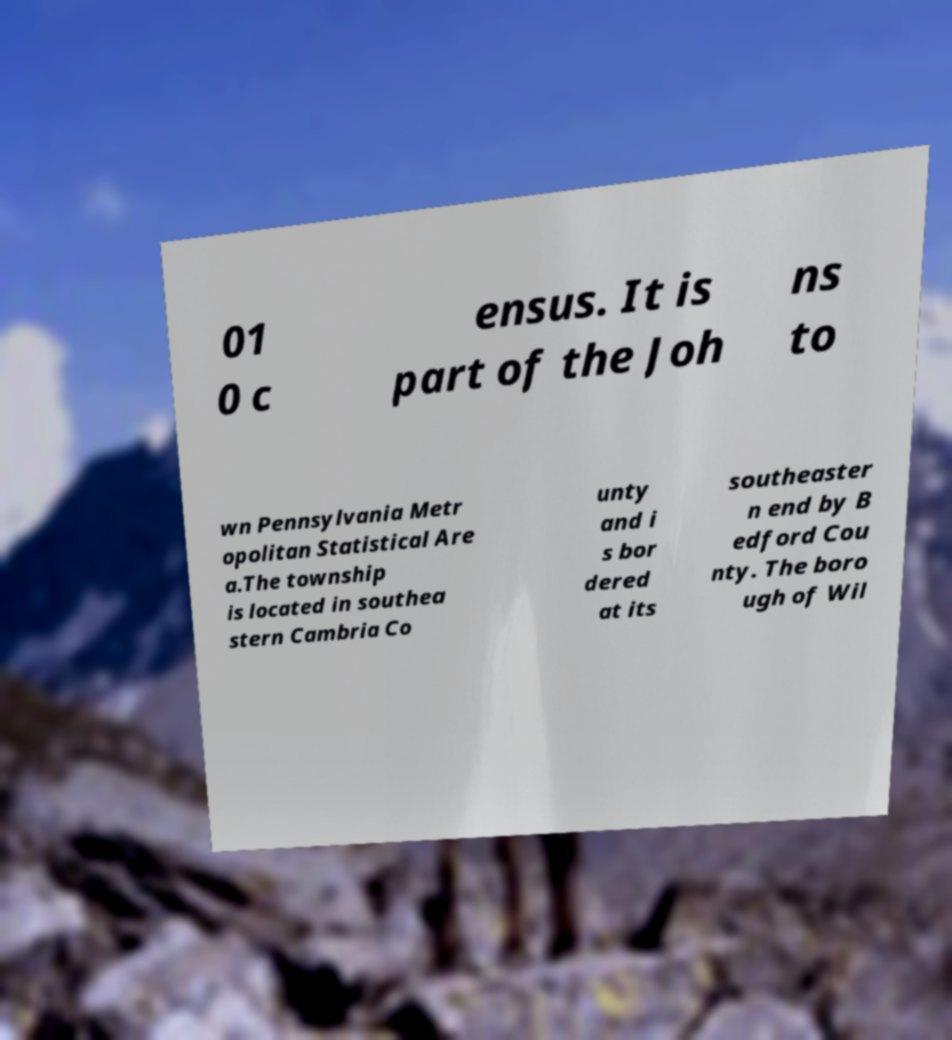Could you extract and type out the text from this image? 01 0 c ensus. It is part of the Joh ns to wn Pennsylvania Metr opolitan Statistical Are a.The township is located in southea stern Cambria Co unty and i s bor dered at its southeaster n end by B edford Cou nty. The boro ugh of Wil 